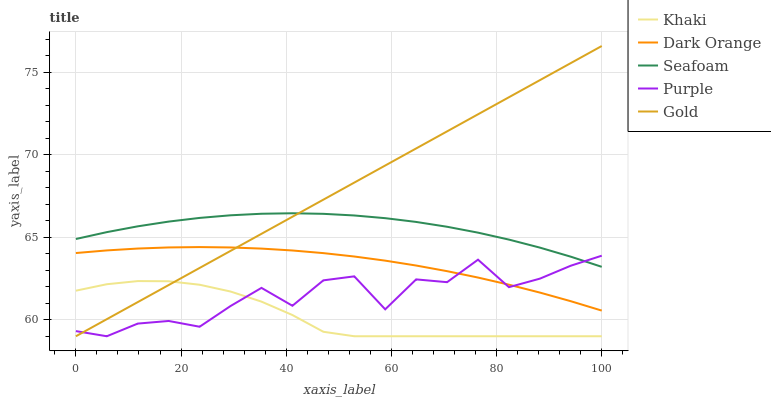Does Khaki have the minimum area under the curve?
Answer yes or no. Yes. Does Gold have the maximum area under the curve?
Answer yes or no. Yes. Does Dark Orange have the minimum area under the curve?
Answer yes or no. No. Does Dark Orange have the maximum area under the curve?
Answer yes or no. No. Is Gold the smoothest?
Answer yes or no. Yes. Is Purple the roughest?
Answer yes or no. Yes. Is Dark Orange the smoothest?
Answer yes or no. No. Is Dark Orange the roughest?
Answer yes or no. No. Does Purple have the lowest value?
Answer yes or no. Yes. Does Dark Orange have the lowest value?
Answer yes or no. No. Does Gold have the highest value?
Answer yes or no. Yes. Does Dark Orange have the highest value?
Answer yes or no. No. Is Dark Orange less than Seafoam?
Answer yes or no. Yes. Is Seafoam greater than Dark Orange?
Answer yes or no. Yes. Does Gold intersect Purple?
Answer yes or no. Yes. Is Gold less than Purple?
Answer yes or no. No. Is Gold greater than Purple?
Answer yes or no. No. Does Dark Orange intersect Seafoam?
Answer yes or no. No. 